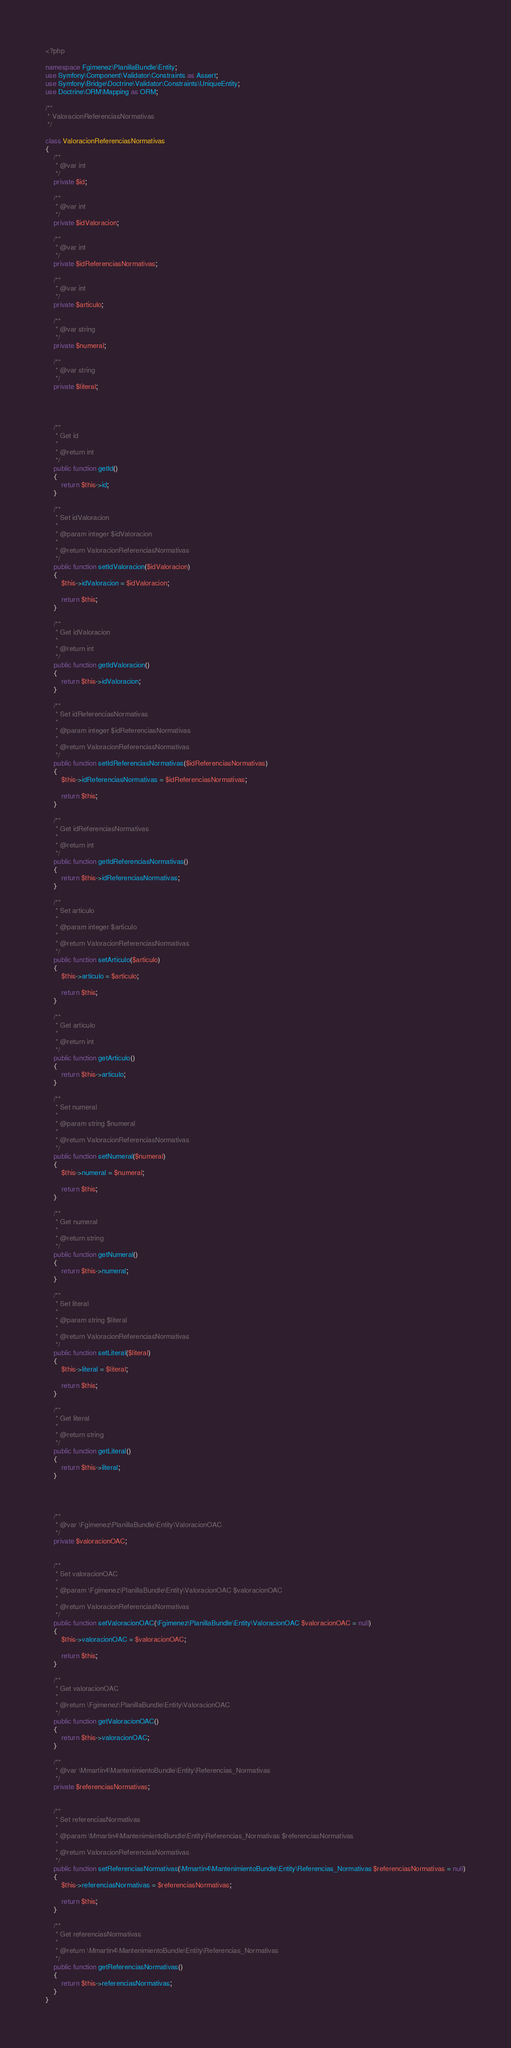<code> <loc_0><loc_0><loc_500><loc_500><_PHP_><?php

namespace Fgimenez\PlanillaBundle\Entity;
use Symfony\Component\Validator\Constraints as Assert;
use Symfony\Bridge\Doctrine\Validator\Constraints\UniqueEntity;
use Doctrine\ORM\Mapping as ORM;

/**
 * ValoracionReferenciasNormativas
 */

class ValoracionReferenciasNormativas
{
    /**
     * @var int
     */
    private $id;

    /**
     * @var int
     */
    private $idValoracion;

    /**
     * @var int
     */
    private $idReferenciasNormativas;

    /**
     * @var int
     */
    private $articulo;

    /**
     * @var string
     */
    private $numeral;

    /**
     * @var string
     */
    private $literal;

    


    /**
     * Get id
     *
     * @return int
     */
    public function getId()
    {
        return $this->id;
    }

    /**
     * Set idValoracion
     *
     * @param integer $idValoracion
     *
     * @return ValoracionReferenciasNormativas
     */
    public function setIdValoracion($idValoracion)
    {
        $this->idValoracion = $idValoracion;

        return $this;
    }

    /**
     * Get idValoracion
     *
     * @return int
     */
    public function getIdValoracion()
    {
        return $this->idValoracion;
    }

    /**
     * Set idReferenciasNormativas
     *
     * @param integer $idReferenciasNormativas
     *
     * @return ValoracionReferenciasNormativas
     */
    public function setIdReferenciasNormativas($idReferenciasNormativas)
    {
        $this->idReferenciasNormativas = $idReferenciasNormativas;

        return $this;
    }

    /**
     * Get idReferenciasNormativas
     *
     * @return int
     */
    public function getIdReferenciasNormativas()
    {
        return $this->idReferenciasNormativas;
    }

    /**
     * Set articulo
     *
     * @param integer $articulo
     *
     * @return ValoracionReferenciasNormativas
     */
    public function setArticulo($articulo)
    {
        $this->articulo = $articulo;

        return $this;
    }

    /**
     * Get articulo
     *
     * @return int
     */
    public function getArticulo()
    {
        return $this->articulo;
    }

    /**
     * Set numeral
     *
     * @param string $numeral
     *
     * @return ValoracionReferenciasNormativas
     */
    public function setNumeral($numeral)
    {
        $this->numeral = $numeral;

        return $this;
    }

    /**
     * Get numeral
     *
     * @return string
     */
    public function getNumeral()
    {
        return $this->numeral;
    }

    /**
     * Set literal
     *
     * @param string $literal
     *
     * @return ValoracionReferenciasNormativas
     */
    public function setLiteral($literal)
    {
        $this->literal = $literal;

        return $this;
    }

    /**
     * Get literal
     *
     * @return string
     */
    public function getLiteral()
    {
        return $this->literal;
    }

    
    
    
    /**
     * @var \Fgimenez\PlanillaBundle\Entity\ValoracionOAC
     */
    private $valoracionOAC;


    /**
     * Set valoracionOAC
     *
     * @param \Fgimenez\PlanillaBundle\Entity\ValoracionOAC $valoracionOAC
     *
     * @return ValoracionReferenciasNormativas
     */
    public function setValoracionOAC(\Fgimenez\PlanillaBundle\Entity\ValoracionOAC $valoracionOAC = null)
    {
        $this->valoracionOAC = $valoracionOAC;

        return $this;
    }

    /**
     * Get valoracionOAC
     *
     * @return \Fgimenez\PlanillaBundle\Entity\ValoracionOAC
     */
    public function getValoracionOAC()
    {
        return $this->valoracionOAC;
    }
    
    /**
     * @var \Mmartin4\MantenimientoBundle\Entity\Referencias_Normativas
     */
    private $referenciasNormativas;


    /**
     * Set referenciasNormativas
     *
     * @param \Mmartin4\MantenimientoBundle\Entity\Referencias_Normativas $referenciasNormativas
     *
     * @return ValoracionReferenciasNormativas
     */
    public function setReferenciasNormativas(\Mmartin4\MantenimientoBundle\Entity\Referencias_Normativas $referenciasNormativas = null)
    {
        $this->referenciasNormativas = $referenciasNormativas;

        return $this;
    }

    /**
     * Get referenciasNormativas
     *
     * @return \Mmartin4\MantenimientoBundle\Entity\Referencias_Normativas
     */
    public function getReferenciasNormativas()
    {
        return $this->referenciasNormativas;
    }
}
</code> 